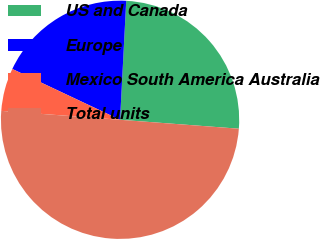Convert chart. <chart><loc_0><loc_0><loc_500><loc_500><pie_chart><fcel>US and Canada<fcel>Europe<fcel>Mexico South America Australia<fcel>Total units<nl><fcel>25.37%<fcel>18.81%<fcel>5.82%<fcel>50.0%<nl></chart> 